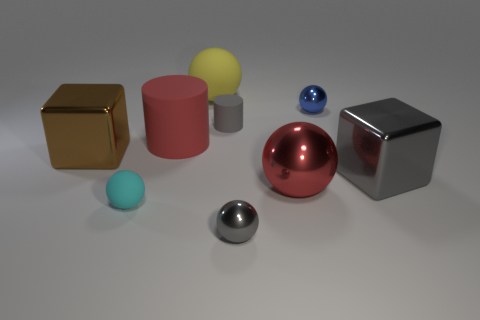Subtract all blue spheres. How many spheres are left? 4 Add 1 small blue shiny balls. How many objects exist? 10 Subtract all brown cylinders. How many brown blocks are left? 1 Subtract all yellow balls. How many balls are left? 4 Subtract 1 cylinders. How many cylinders are left? 1 Subtract all gray cubes. Subtract all yellow cylinders. How many cubes are left? 1 Subtract all blocks. Subtract all red things. How many objects are left? 5 Add 8 gray shiny objects. How many gray shiny objects are left? 10 Add 1 yellow rubber balls. How many yellow rubber balls exist? 2 Subtract 1 gray cylinders. How many objects are left? 8 